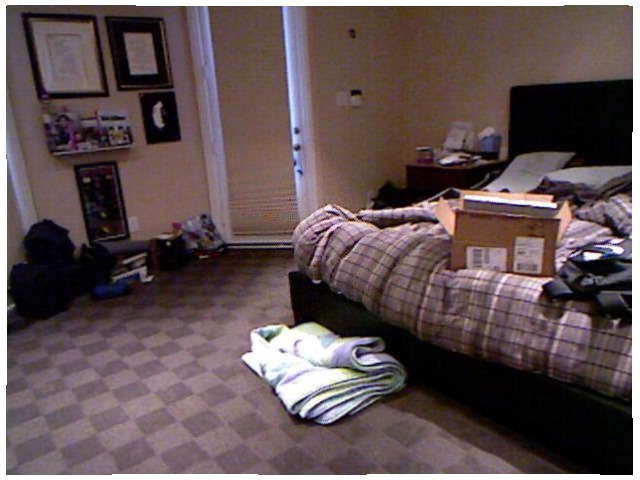<image>
Is the blanket on the floor? Yes. Looking at the image, I can see the blanket is positioned on top of the floor, with the floor providing support. Is there a box on the bed? Yes. Looking at the image, I can see the box is positioned on top of the bed, with the bed providing support. Is the box on the floor? No. The box is not positioned on the floor. They may be near each other, but the box is not supported by or resting on top of the floor. Is there a blanket on the bed? No. The blanket is not positioned on the bed. They may be near each other, but the blanket is not supported by or resting on top of the bed. 